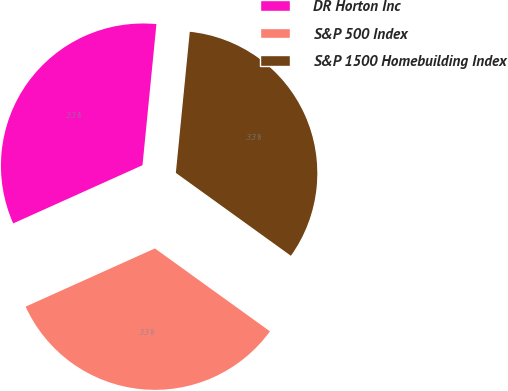Convert chart to OTSL. <chart><loc_0><loc_0><loc_500><loc_500><pie_chart><fcel>DR Horton Inc<fcel>S&P 500 Index<fcel>S&P 1500 Homebuilding Index<nl><fcel>33.3%<fcel>33.33%<fcel>33.37%<nl></chart> 